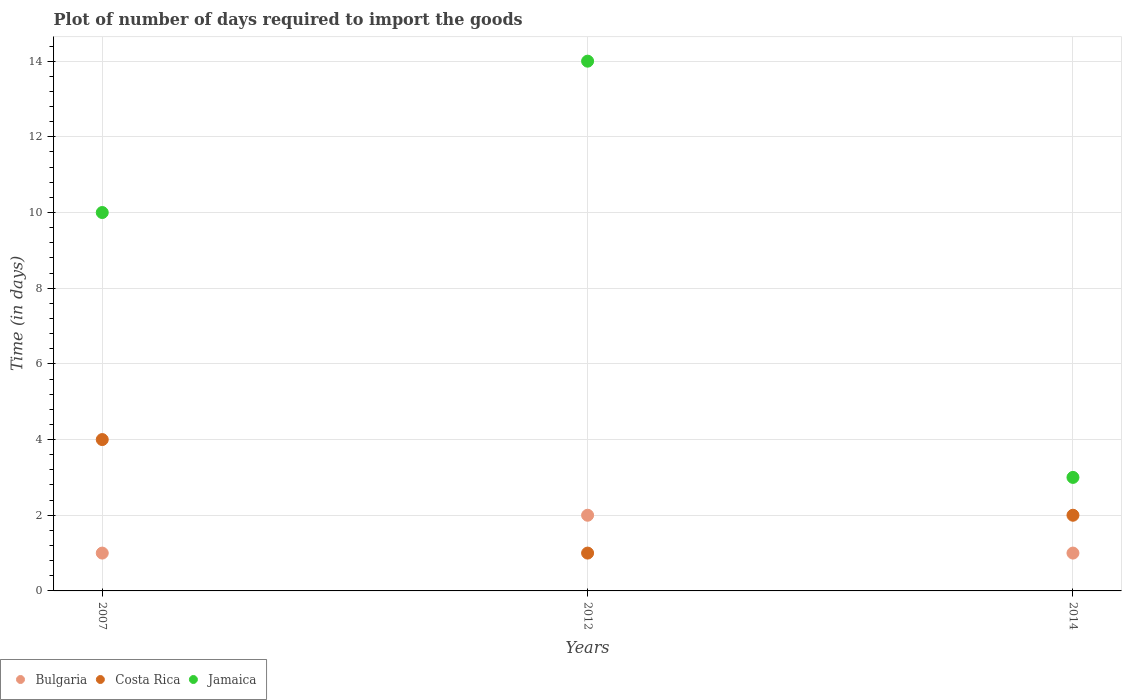How many different coloured dotlines are there?
Make the answer very short. 3. What is the time required to import goods in Costa Rica in 2014?
Make the answer very short. 2. Across all years, what is the maximum time required to import goods in Costa Rica?
Your answer should be compact. 4. Across all years, what is the minimum time required to import goods in Costa Rica?
Give a very brief answer. 1. In which year was the time required to import goods in Jamaica maximum?
Your response must be concise. 2012. In which year was the time required to import goods in Jamaica minimum?
Your answer should be very brief. 2014. What is the total time required to import goods in Bulgaria in the graph?
Your answer should be compact. 4. What is the difference between the time required to import goods in Jamaica in 2007 and that in 2014?
Your response must be concise. 7. What is the difference between the time required to import goods in Costa Rica in 2014 and the time required to import goods in Jamaica in 2007?
Your response must be concise. -8. What is the average time required to import goods in Costa Rica per year?
Give a very brief answer. 2.33. In the year 2007, what is the difference between the time required to import goods in Bulgaria and time required to import goods in Costa Rica?
Provide a short and direct response. -3. In how many years, is the time required to import goods in Jamaica greater than 3.6 days?
Keep it short and to the point. 2. What is the ratio of the time required to import goods in Bulgaria in 2007 to that in 2014?
Make the answer very short. 1. Is the time required to import goods in Jamaica in 2007 less than that in 2014?
Give a very brief answer. No. What is the difference between the highest and the second highest time required to import goods in Costa Rica?
Your response must be concise. 2. In how many years, is the time required to import goods in Bulgaria greater than the average time required to import goods in Bulgaria taken over all years?
Make the answer very short. 1. Is it the case that in every year, the sum of the time required to import goods in Costa Rica and time required to import goods in Jamaica  is greater than the time required to import goods in Bulgaria?
Your answer should be very brief. Yes. Does the time required to import goods in Costa Rica monotonically increase over the years?
Provide a short and direct response. No. How many dotlines are there?
Provide a succinct answer. 3. How many years are there in the graph?
Your response must be concise. 3. What is the difference between two consecutive major ticks on the Y-axis?
Your response must be concise. 2. Does the graph contain any zero values?
Provide a short and direct response. No. What is the title of the graph?
Offer a very short reply. Plot of number of days required to import the goods. Does "World" appear as one of the legend labels in the graph?
Keep it short and to the point. No. What is the label or title of the X-axis?
Your response must be concise. Years. What is the label or title of the Y-axis?
Offer a very short reply. Time (in days). What is the Time (in days) of Jamaica in 2007?
Offer a very short reply. 10. What is the Time (in days) of Bulgaria in 2012?
Offer a very short reply. 2. What is the Time (in days) of Jamaica in 2012?
Provide a succinct answer. 14. What is the Time (in days) in Bulgaria in 2014?
Ensure brevity in your answer.  1. Across all years, what is the maximum Time (in days) of Costa Rica?
Your response must be concise. 4. Across all years, what is the minimum Time (in days) of Bulgaria?
Offer a terse response. 1. What is the total Time (in days) in Jamaica in the graph?
Offer a very short reply. 27. What is the difference between the Time (in days) of Costa Rica in 2007 and that in 2012?
Offer a very short reply. 3. What is the difference between the Time (in days) in Jamaica in 2007 and that in 2012?
Provide a short and direct response. -4. What is the difference between the Time (in days) in Jamaica in 2007 and that in 2014?
Your answer should be compact. 7. What is the difference between the Time (in days) of Bulgaria in 2007 and the Time (in days) of Costa Rica in 2012?
Ensure brevity in your answer.  0. What is the difference between the Time (in days) in Bulgaria in 2007 and the Time (in days) in Jamaica in 2012?
Offer a terse response. -13. What is the difference between the Time (in days) of Bulgaria in 2007 and the Time (in days) of Costa Rica in 2014?
Your response must be concise. -1. What is the difference between the Time (in days) in Costa Rica in 2007 and the Time (in days) in Jamaica in 2014?
Your answer should be very brief. 1. What is the difference between the Time (in days) of Bulgaria in 2012 and the Time (in days) of Costa Rica in 2014?
Give a very brief answer. 0. What is the difference between the Time (in days) of Bulgaria in 2012 and the Time (in days) of Jamaica in 2014?
Your answer should be compact. -1. What is the difference between the Time (in days) in Costa Rica in 2012 and the Time (in days) in Jamaica in 2014?
Provide a short and direct response. -2. What is the average Time (in days) of Bulgaria per year?
Offer a terse response. 1.33. What is the average Time (in days) in Costa Rica per year?
Give a very brief answer. 2.33. In the year 2007, what is the difference between the Time (in days) of Bulgaria and Time (in days) of Costa Rica?
Provide a succinct answer. -3. In the year 2007, what is the difference between the Time (in days) in Bulgaria and Time (in days) in Jamaica?
Provide a short and direct response. -9. In the year 2007, what is the difference between the Time (in days) of Costa Rica and Time (in days) of Jamaica?
Give a very brief answer. -6. In the year 2012, what is the difference between the Time (in days) in Costa Rica and Time (in days) in Jamaica?
Ensure brevity in your answer.  -13. In the year 2014, what is the difference between the Time (in days) in Bulgaria and Time (in days) in Costa Rica?
Provide a short and direct response. -1. In the year 2014, what is the difference between the Time (in days) in Bulgaria and Time (in days) in Jamaica?
Provide a succinct answer. -2. What is the ratio of the Time (in days) in Jamaica in 2007 to that in 2012?
Your answer should be compact. 0.71. What is the ratio of the Time (in days) of Bulgaria in 2007 to that in 2014?
Offer a very short reply. 1. What is the ratio of the Time (in days) in Jamaica in 2012 to that in 2014?
Provide a succinct answer. 4.67. What is the difference between the highest and the second highest Time (in days) of Bulgaria?
Keep it short and to the point. 1. What is the difference between the highest and the second highest Time (in days) of Jamaica?
Keep it short and to the point. 4. What is the difference between the highest and the lowest Time (in days) in Jamaica?
Provide a succinct answer. 11. 